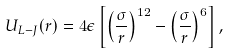Convert formula to latex. <formula><loc_0><loc_0><loc_500><loc_500>U _ { L - J } ( r ) = 4 \epsilon \left [ \left ( \frac { \sigma } { r } \right ) ^ { 1 2 } - \left ( \frac { \sigma } { r } \right ) ^ { 6 } \right ] ,</formula> 